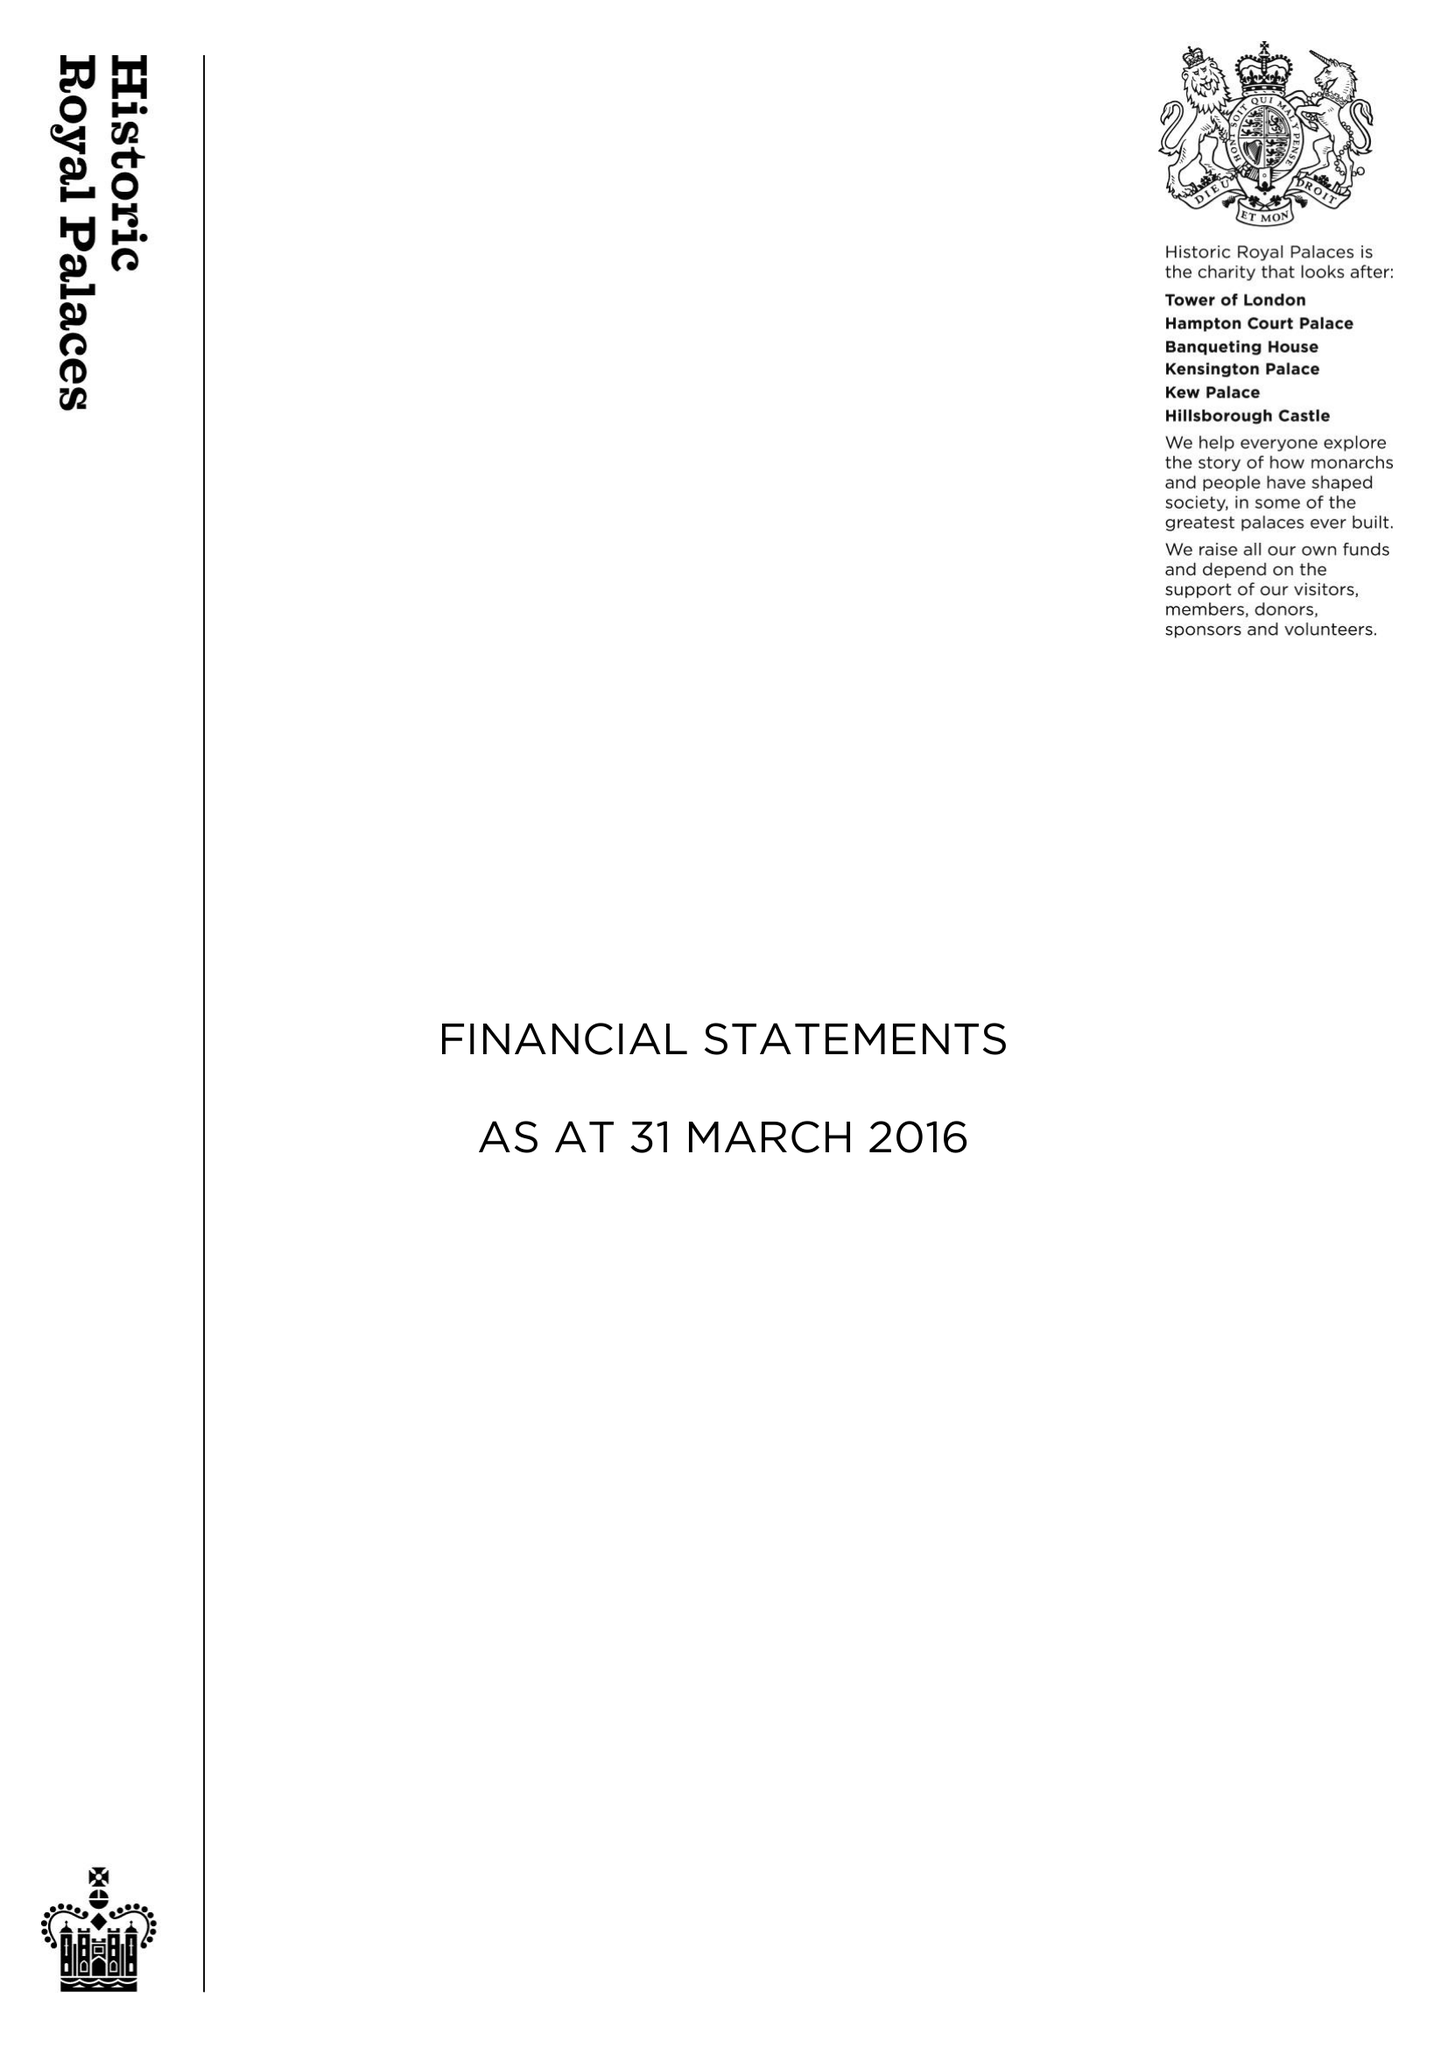What is the value for the income_annually_in_british_pounds?
Answer the question using a single word or phrase. 86555000.00 